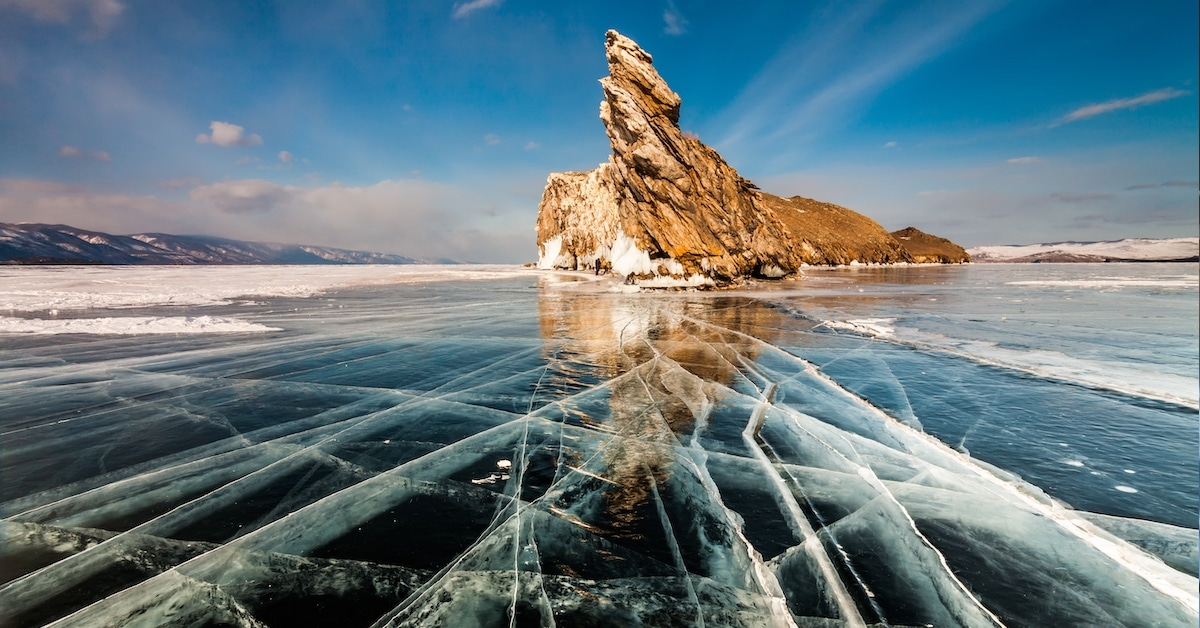What can you tell me about the geography and formation of this rock structure in Lake Baikal? The prominent rock structure in Lake Baikal shown in the image is known as Shaman Rock. It is a sacred site for locals, steeped in folklore and religious significance. Geologically, the rock is formed primarily from shamanite, a unique type of limestone found in this area. Its distinct appearance is due to centuries of erosion by the wind and freezing temperatures, sculpting it into the jagged formation seen today. 